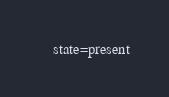Convert code to text. <code><loc_0><loc_0><loc_500><loc_500><_YAML_>    state=present
</code> 